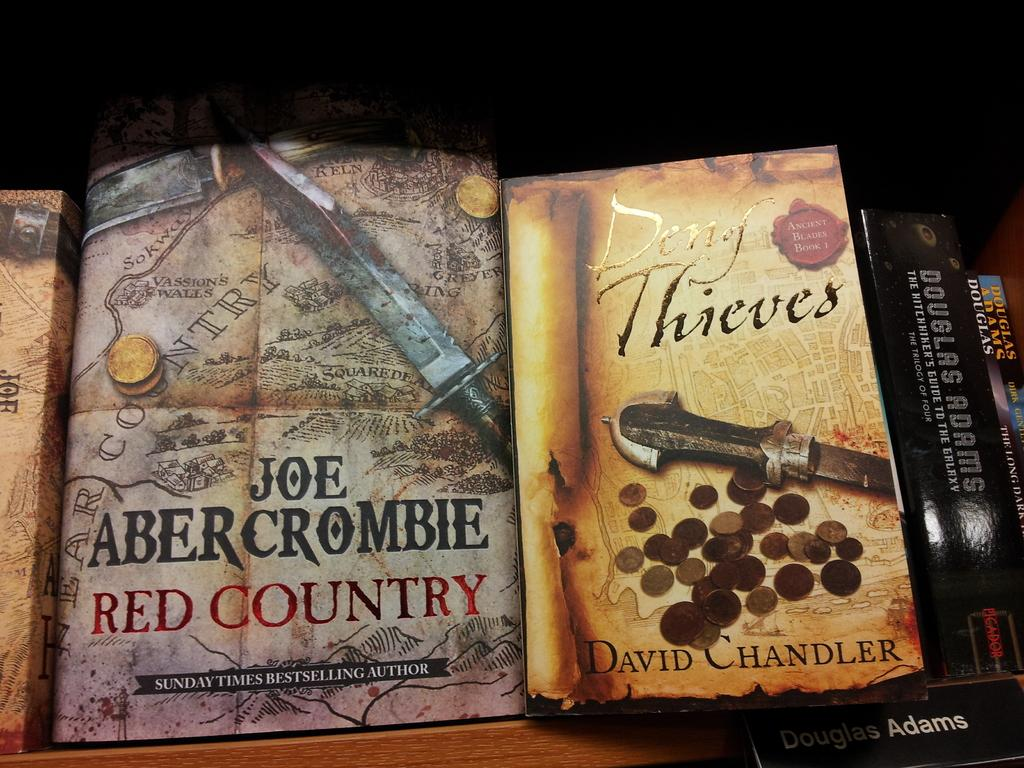<image>
Write a terse but informative summary of the picture. Red Country was written by Joe Abercrombie, and the other book is a David Chandler book. 